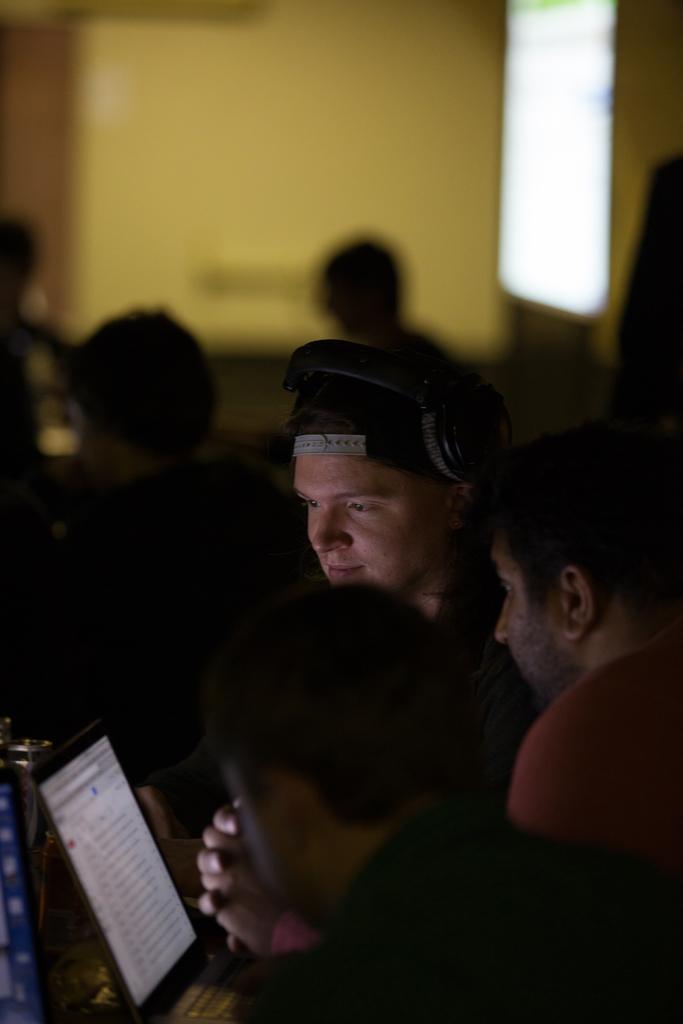How would you summarize this image in a sentence or two? This image consists of three persons in the front are using laptop. we can see a person wearing headset. In the background, there are two persons and the background is blurred. And we can see a wall in yellow color. 